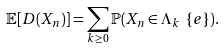Convert formula to latex. <formula><loc_0><loc_0><loc_500><loc_500>\mathbb { E } [ D ( X _ { n } ) ] = \sum _ { k \geq 0 } \mathbb { P } ( X _ { n } \in \Lambda _ { k } \ \{ e \} ) .</formula> 